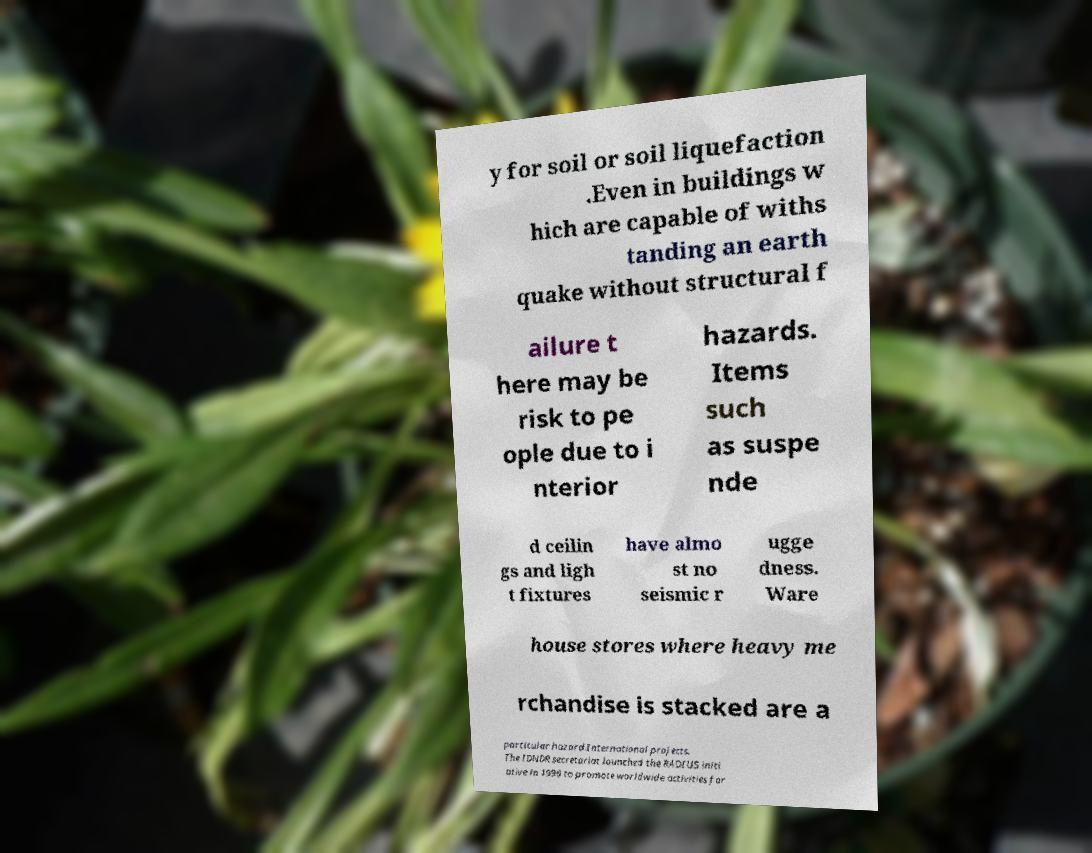Could you extract and type out the text from this image? y for soil or soil liquefaction .Even in buildings w hich are capable of withs tanding an earth quake without structural f ailure t here may be risk to pe ople due to i nterior hazards. Items such as suspe nde d ceilin gs and ligh t fixtures have almo st no seismic r ugge dness. Ware house stores where heavy me rchandise is stacked are a particular hazard.International projects. The IDNDR secretariat launched the RADIUS initi ative in 1996 to promote worldwide activities for 